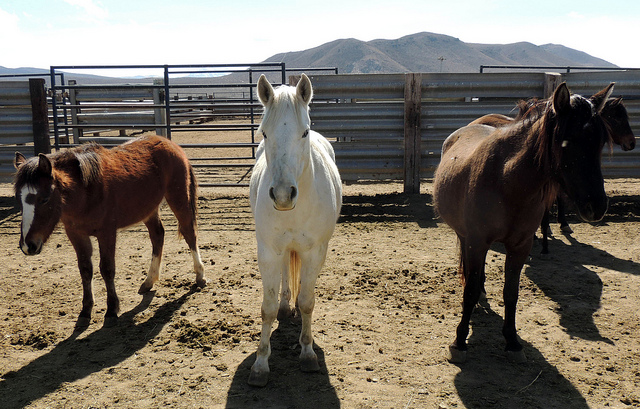<image>What is the name of the marking that appears on the horse on the left's face? I don't know the exact name of the marking that appears on the horse's face on the left side. It could be a brand, circle, spot, 'c', diamond or branding. What is the name of the marking that appears on the horse on the left's face? I don't know the name of the marking that appears on the horse on the left's face. It can be a brand, circle, spot, or diamond. 